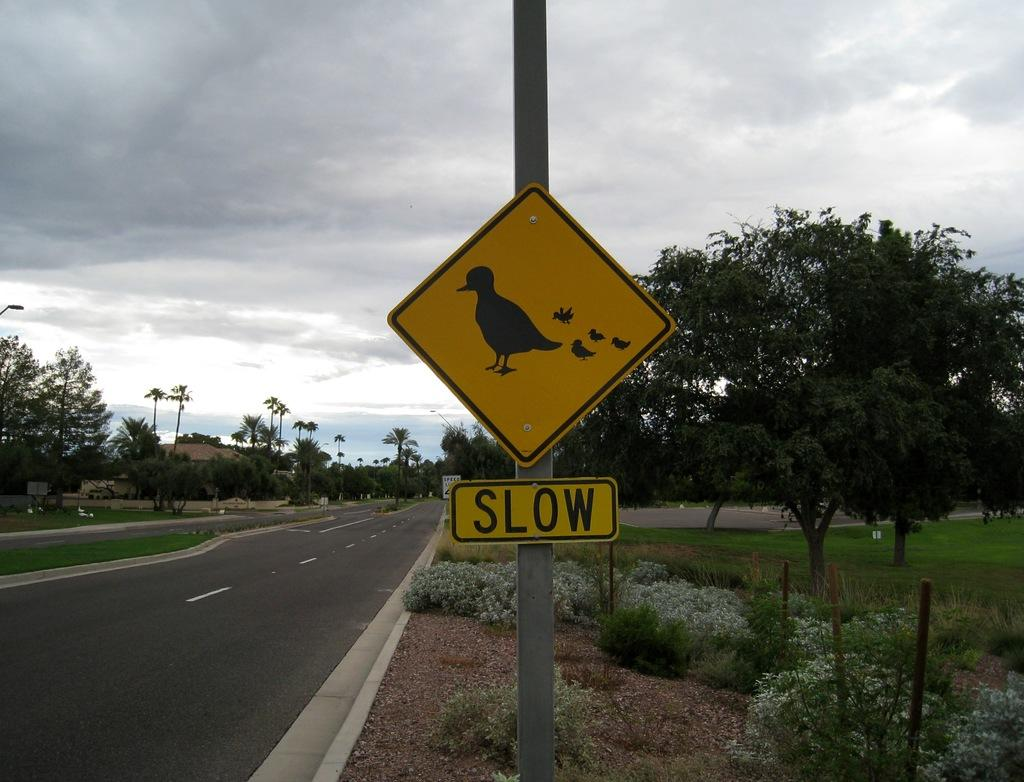<image>
Provide a brief description of the given image. A sign with a picture of birds on it tells drivers to go slow. 